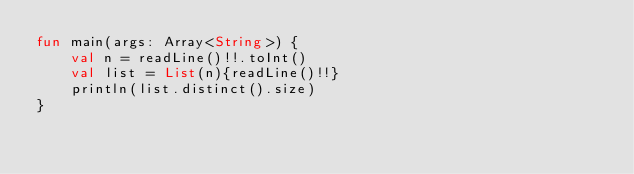<code> <loc_0><loc_0><loc_500><loc_500><_Kotlin_>fun main(args: Array<String>) {
    val n = readLine()!!.toInt()
    val list = List(n){readLine()!!}
    println(list.distinct().size)
}</code> 